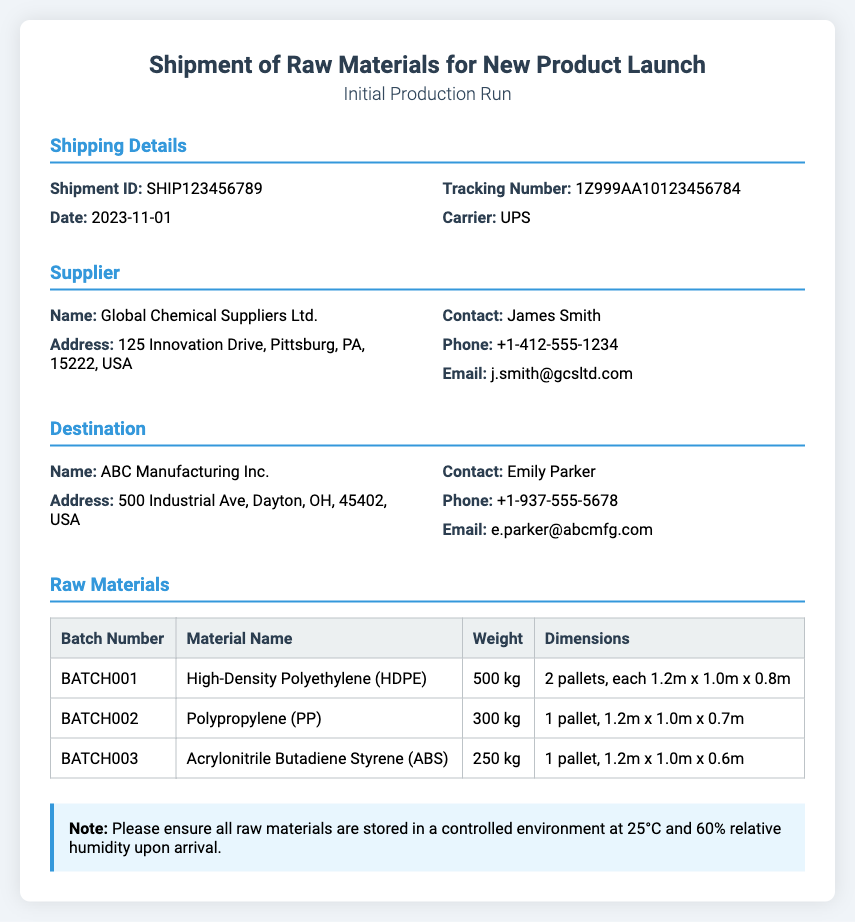What is the Shipment ID? The Shipment ID can be found under the Shipping Details section, which identifies the specific shipment.
Answer: SHIP123456789 Who is the supplier of the raw materials? The supplier's name is located in the Supplier section, detailing who provided the materials.
Answer: Global Chemical Suppliers Ltd What is the weight of Polypropylene (PP)? The weight can be found in the Raw Materials section, specifically listed under the material name.
Answer: 300 kg What is the date of shipment? The date is listed in the Shipping Details section, indicating when the shipment was processed.
Answer: 2023-11-01 How many pallets does the High-Density Polyethylene (HDPE) consist of? The number of pallets can be determined from the dimensions mentioned in the Raw Materials section.
Answer: 2 pallets What is the email address of the supplier contact? The supplier contact's email is provided in the details section of the document.
Answer: j.smith@gcsltd.com What temperature should raw materials be stored at upon arrival? The storage temperature requirement is noted in the notes section of the document.
Answer: 25°C What batch number corresponds to Acrylonitrile Butadiene Styrene (ABS)? The batch number can be found by referencing the Raw Materials section and the corresponding material name.
Answer: BATCH003 Who is the contact person at the destination? The contact person for the destination is mentioned in the Destination section of the document.
Answer: Emily Parker 